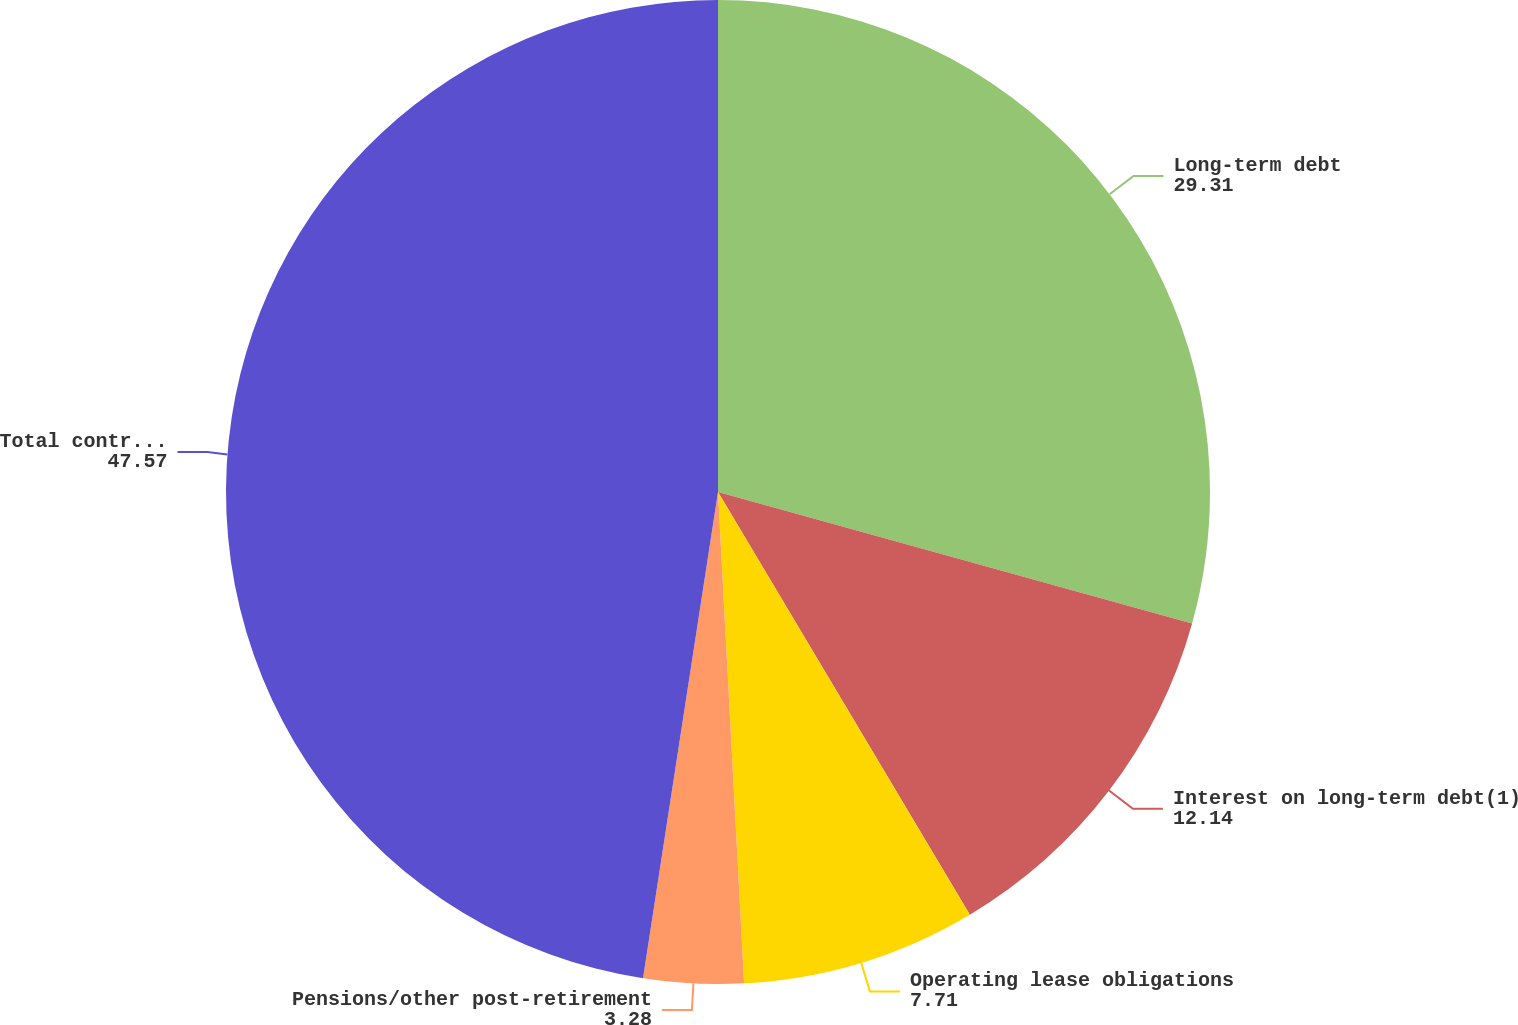<chart> <loc_0><loc_0><loc_500><loc_500><pie_chart><fcel>Long-term debt<fcel>Interest on long-term debt(1)<fcel>Operating lease obligations<fcel>Pensions/other post-retirement<fcel>Total contractual obligations<nl><fcel>29.31%<fcel>12.14%<fcel>7.71%<fcel>3.28%<fcel>47.57%<nl></chart> 